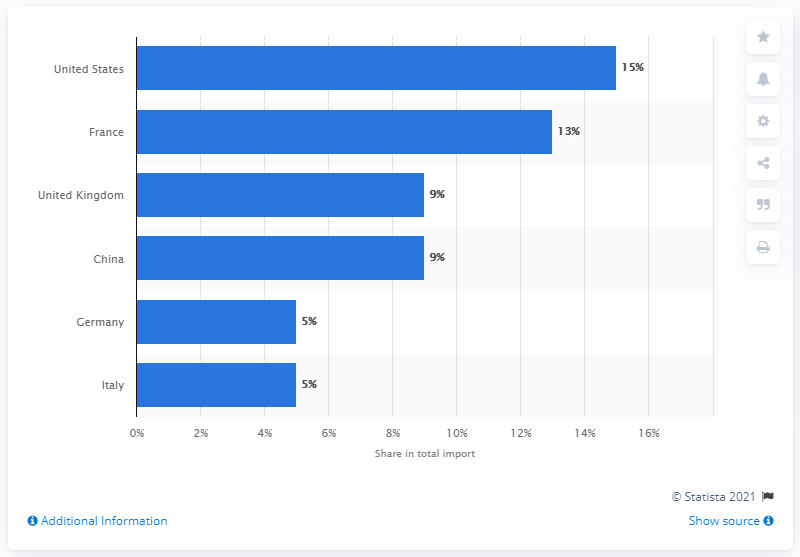Point out several critical features in this image. The United States has the highest total imports among all countries. The average of the two modes is 7. In 2019, the United States was Qatar's most important import partner. 